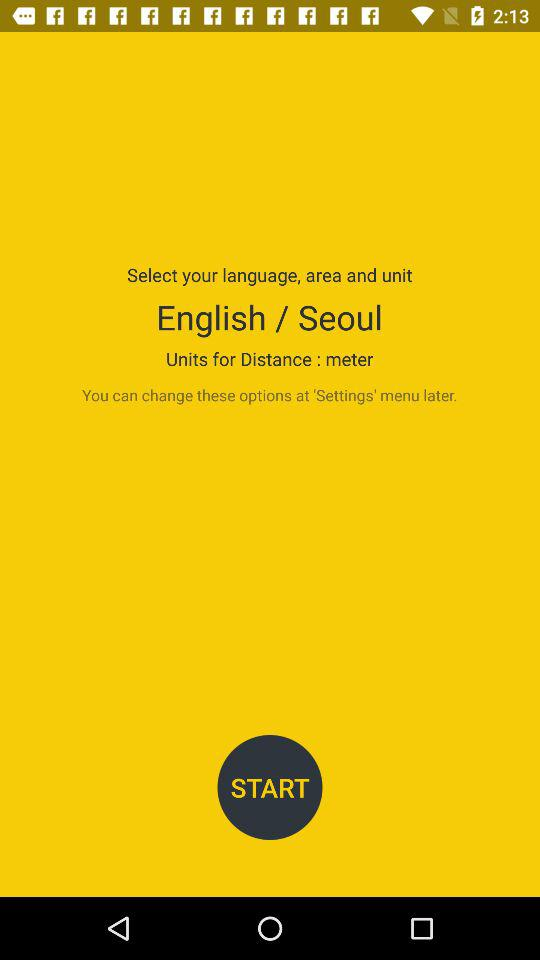What are the "Units for Distance"? The unit is a meter. 